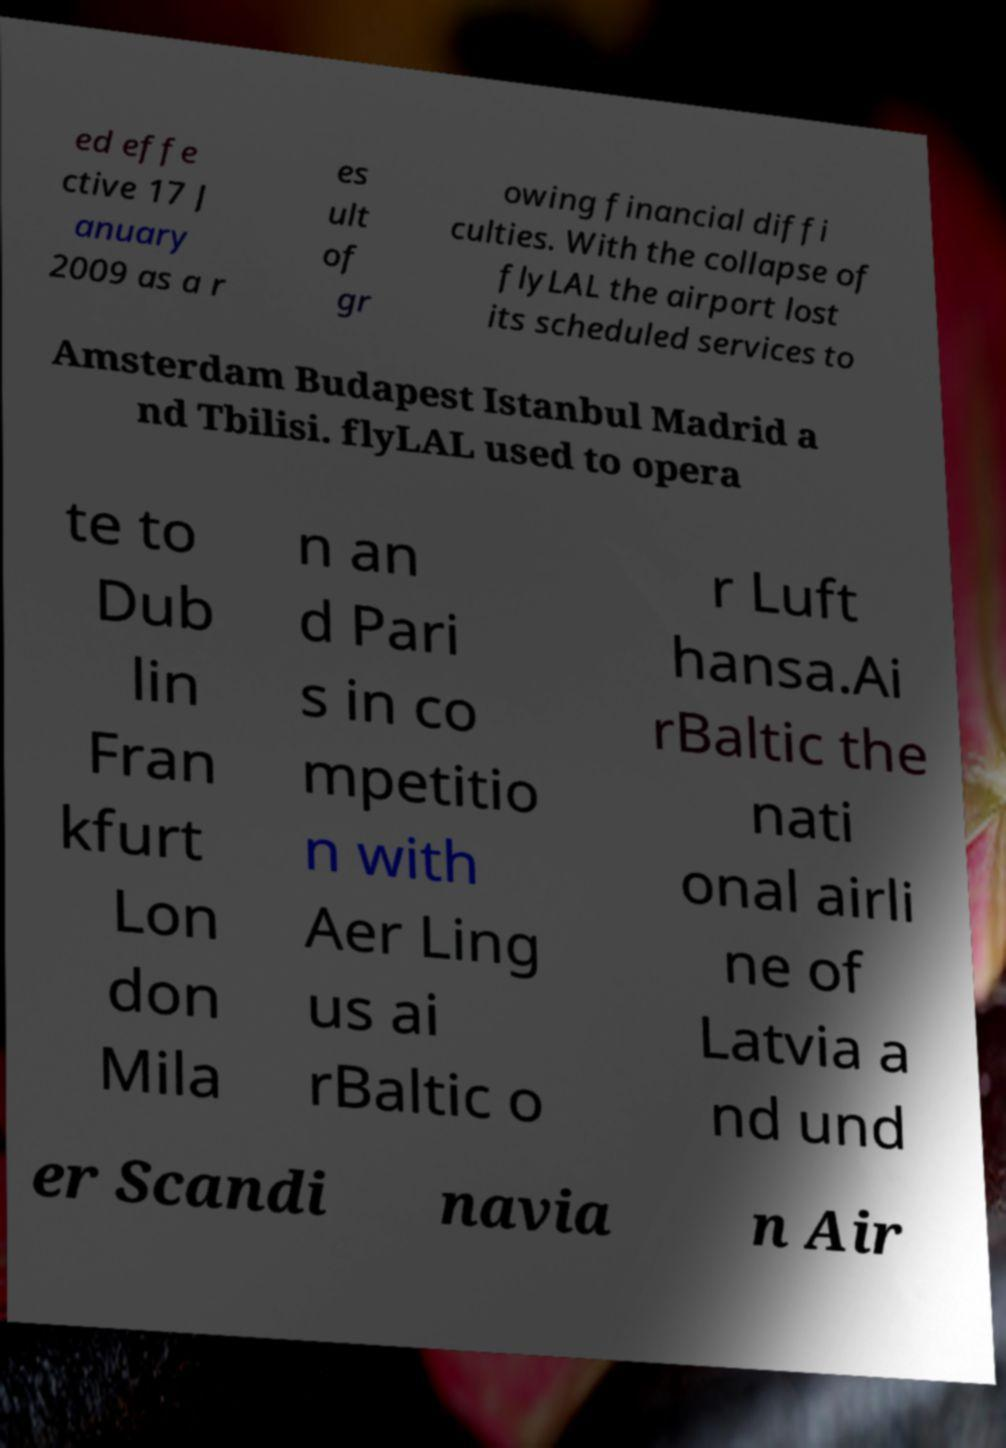Could you extract and type out the text from this image? ed effe ctive 17 J anuary 2009 as a r es ult of gr owing financial diffi culties. With the collapse of flyLAL the airport lost its scheduled services to Amsterdam Budapest Istanbul Madrid a nd Tbilisi. flyLAL used to opera te to Dub lin Fran kfurt Lon don Mila n an d Pari s in co mpetitio n with Aer Ling us ai rBaltic o r Luft hansa.Ai rBaltic the nati onal airli ne of Latvia a nd und er Scandi navia n Air 